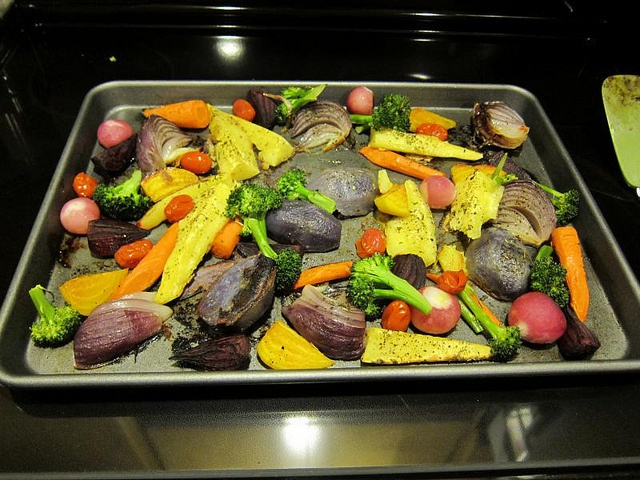Describe the objects in this image and their specific colors. I can see broccoli in gray, lime, black, darkgreen, and olive tones, broccoli in gray, black, darkgreen, and olive tones, broccoli in gray, black, darkgreen, and lime tones, broccoli in gray, olive, black, and darkgreen tones, and carrot in gray, orange, and olive tones in this image. 